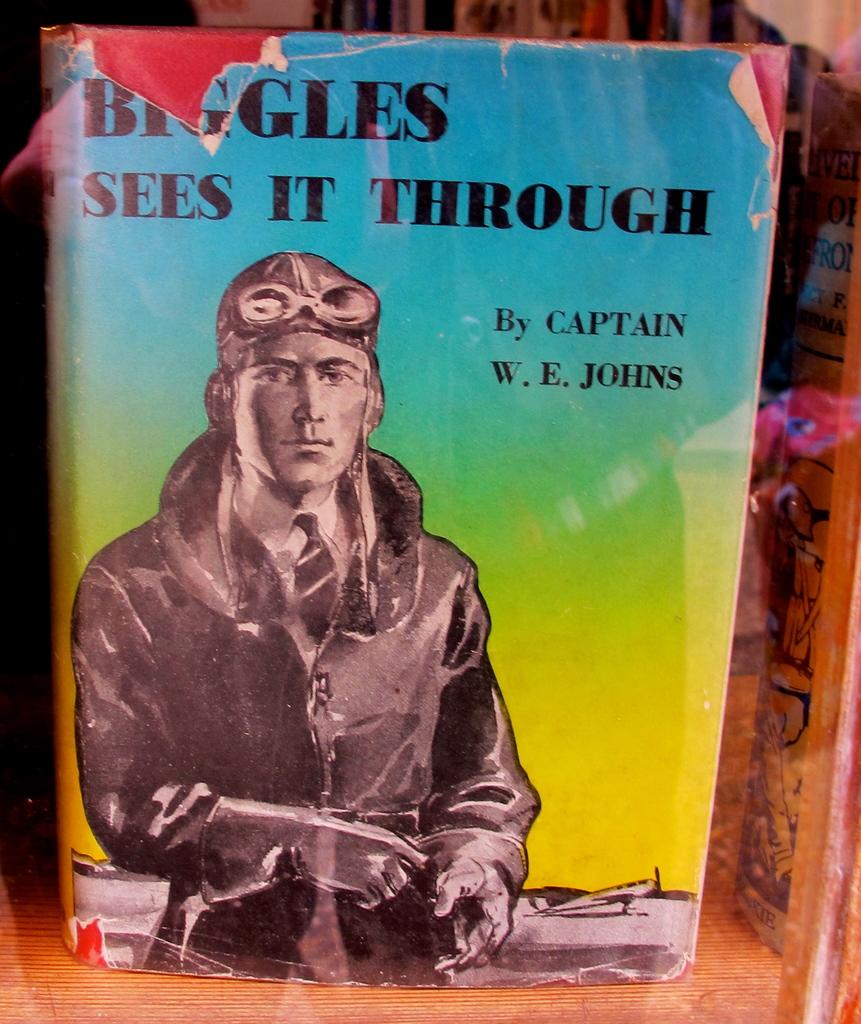What is the title of the work?
Your response must be concise. Biggles sees it through. 